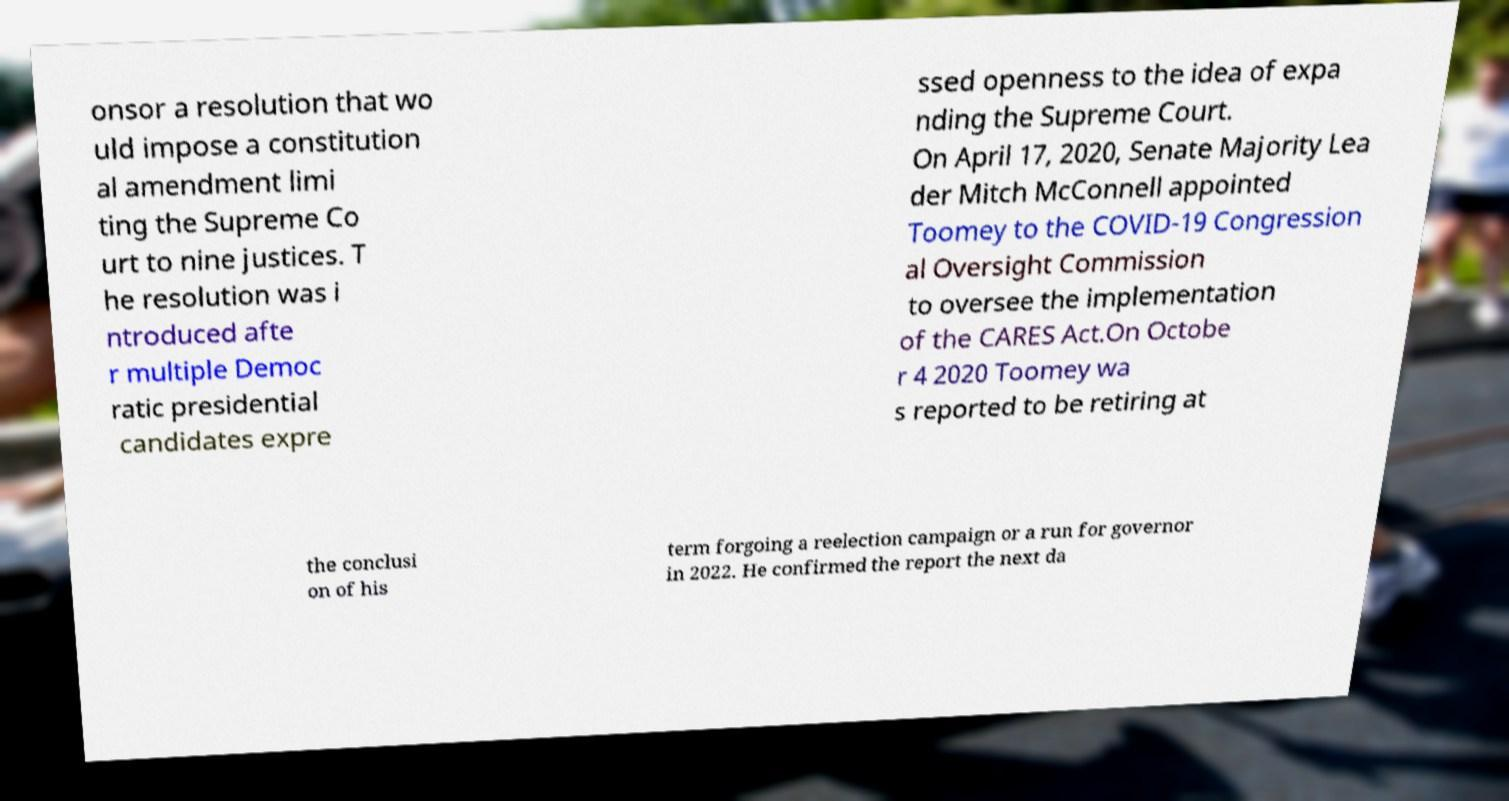Can you accurately transcribe the text from the provided image for me? onsor a resolution that wo uld impose a constitution al amendment limi ting the Supreme Co urt to nine justices. T he resolution was i ntroduced afte r multiple Democ ratic presidential candidates expre ssed openness to the idea of expa nding the Supreme Court. On April 17, 2020, Senate Majority Lea der Mitch McConnell appointed Toomey to the COVID-19 Congression al Oversight Commission to oversee the implementation of the CARES Act.On Octobe r 4 2020 Toomey wa s reported to be retiring at the conclusi on of his term forgoing a reelection campaign or a run for governor in 2022. He confirmed the report the next da 